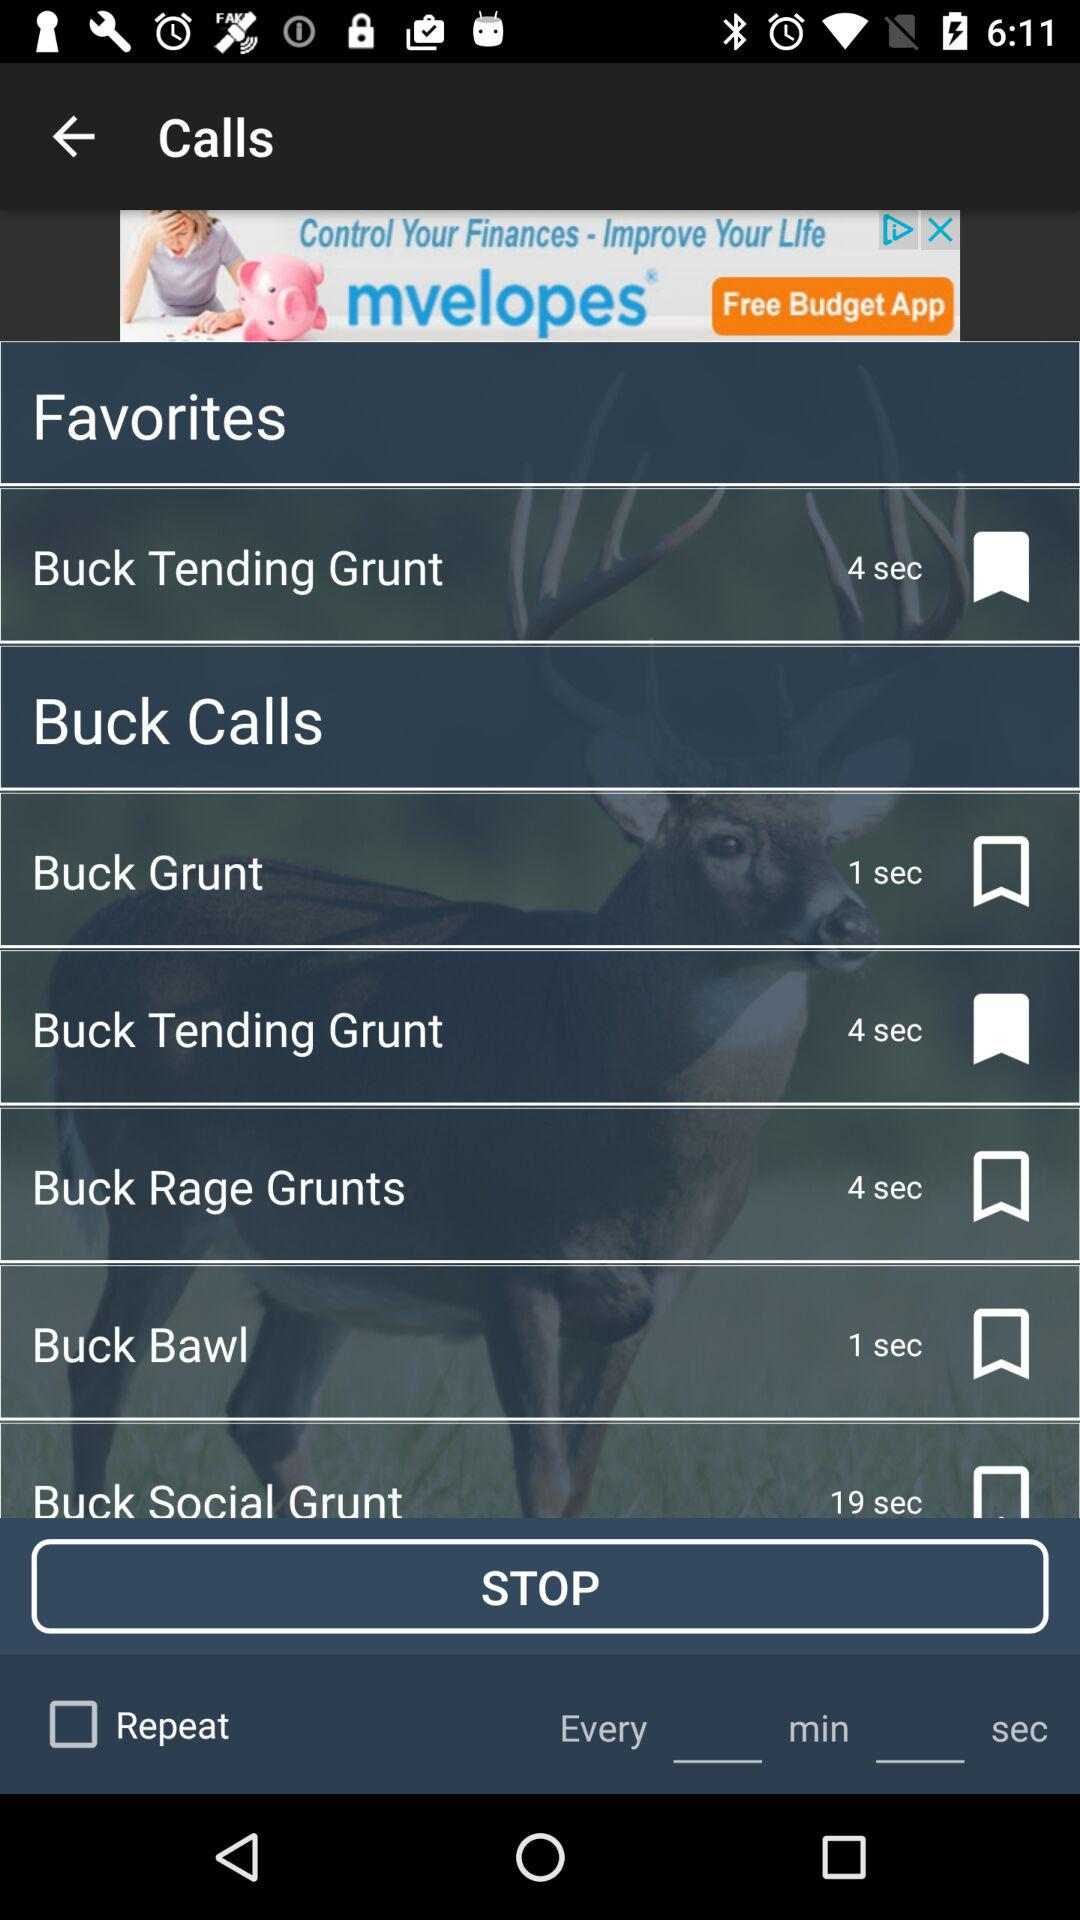How many calls are not bookmarked?
Answer the question using a single word or phrase. 4 